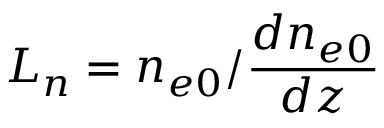<formula> <loc_0><loc_0><loc_500><loc_500>L _ { n } = n _ { e 0 } / \frac { d n _ { e 0 } } { d z }</formula> 